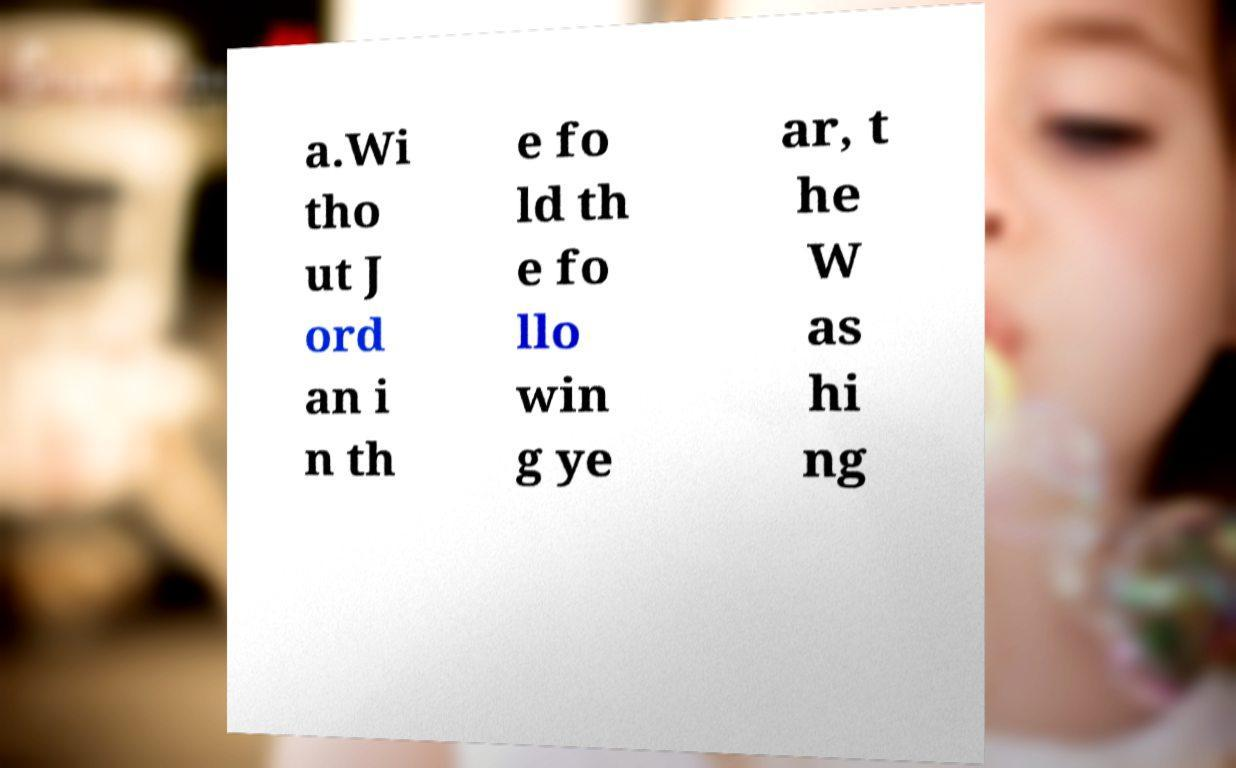Could you assist in decoding the text presented in this image and type it out clearly? a.Wi tho ut J ord an i n th e fo ld th e fo llo win g ye ar, t he W as hi ng 